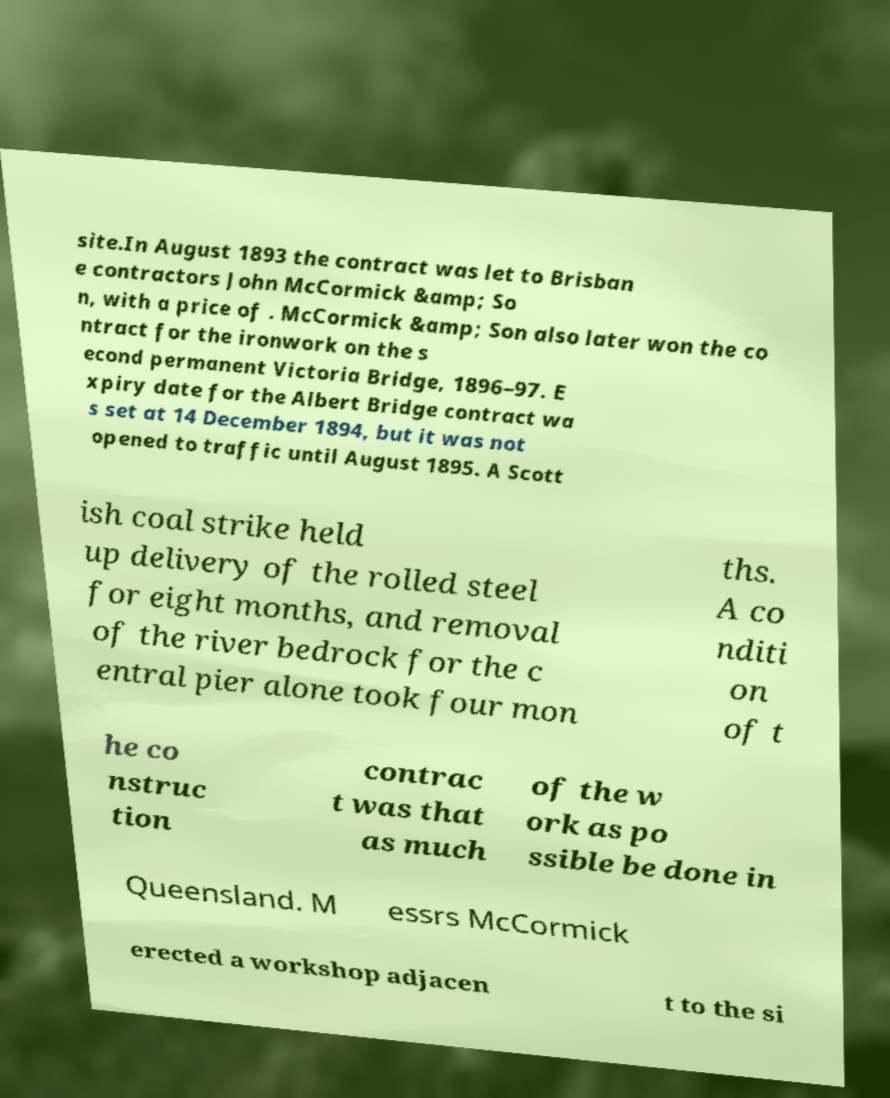Can you read and provide the text displayed in the image?This photo seems to have some interesting text. Can you extract and type it out for me? site.In August 1893 the contract was let to Brisban e contractors John McCormick &amp; So n, with a price of . McCormick &amp; Son also later won the co ntract for the ironwork on the s econd permanent Victoria Bridge, 1896–97. E xpiry date for the Albert Bridge contract wa s set at 14 December 1894, but it was not opened to traffic until August 1895. A Scott ish coal strike held up delivery of the rolled steel for eight months, and removal of the river bedrock for the c entral pier alone took four mon ths. A co nditi on of t he co nstruc tion contrac t was that as much of the w ork as po ssible be done in Queensland. M essrs McCormick erected a workshop adjacen t to the si 